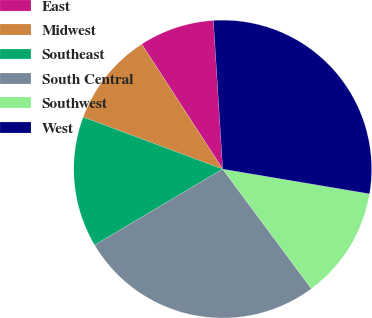<chart> <loc_0><loc_0><loc_500><loc_500><pie_chart><fcel>East<fcel>Midwest<fcel>Southeast<fcel>South Central<fcel>Southwest<fcel>West<nl><fcel>8.16%<fcel>10.17%<fcel>14.2%<fcel>26.64%<fcel>12.19%<fcel>28.65%<nl></chart> 